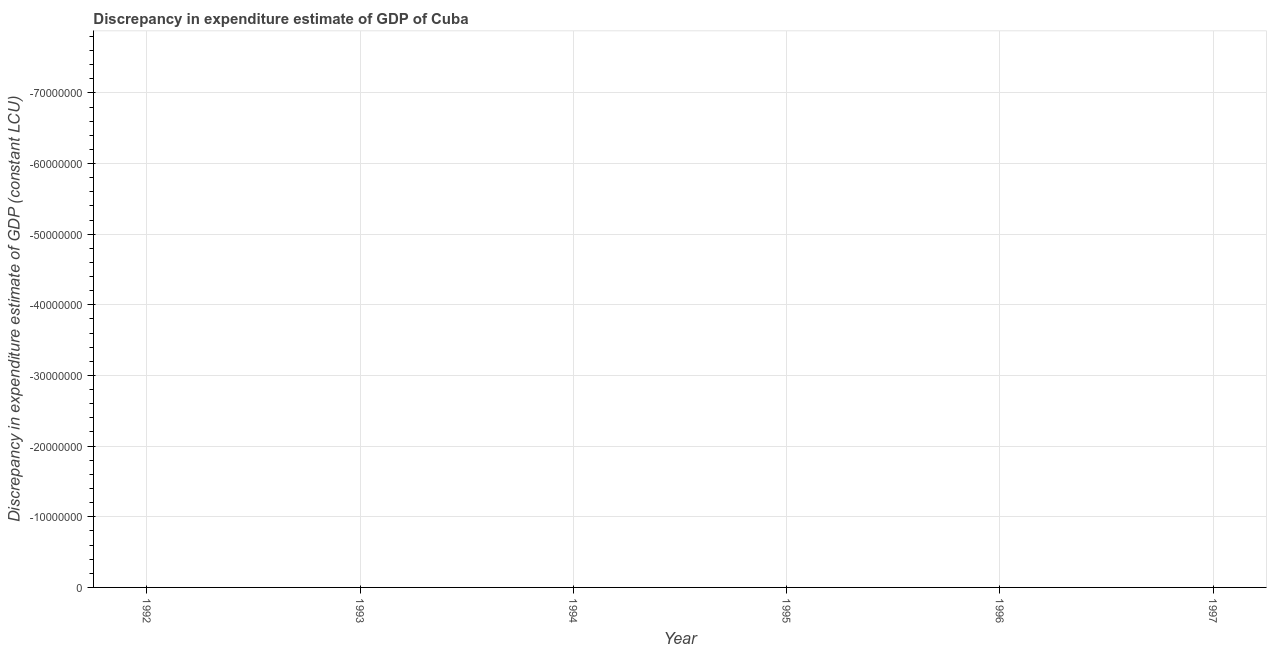Across all years, what is the minimum discrepancy in expenditure estimate of gdp?
Make the answer very short. 0. What is the sum of the discrepancy in expenditure estimate of gdp?
Give a very brief answer. 0. Does the graph contain any zero values?
Your answer should be very brief. Yes. Does the graph contain grids?
Keep it short and to the point. Yes. What is the title of the graph?
Your answer should be compact. Discrepancy in expenditure estimate of GDP of Cuba. What is the label or title of the X-axis?
Your answer should be very brief. Year. What is the label or title of the Y-axis?
Ensure brevity in your answer.  Discrepancy in expenditure estimate of GDP (constant LCU). What is the Discrepancy in expenditure estimate of GDP (constant LCU) in 1995?
Ensure brevity in your answer.  0. What is the Discrepancy in expenditure estimate of GDP (constant LCU) of 1997?
Your response must be concise. 0. 